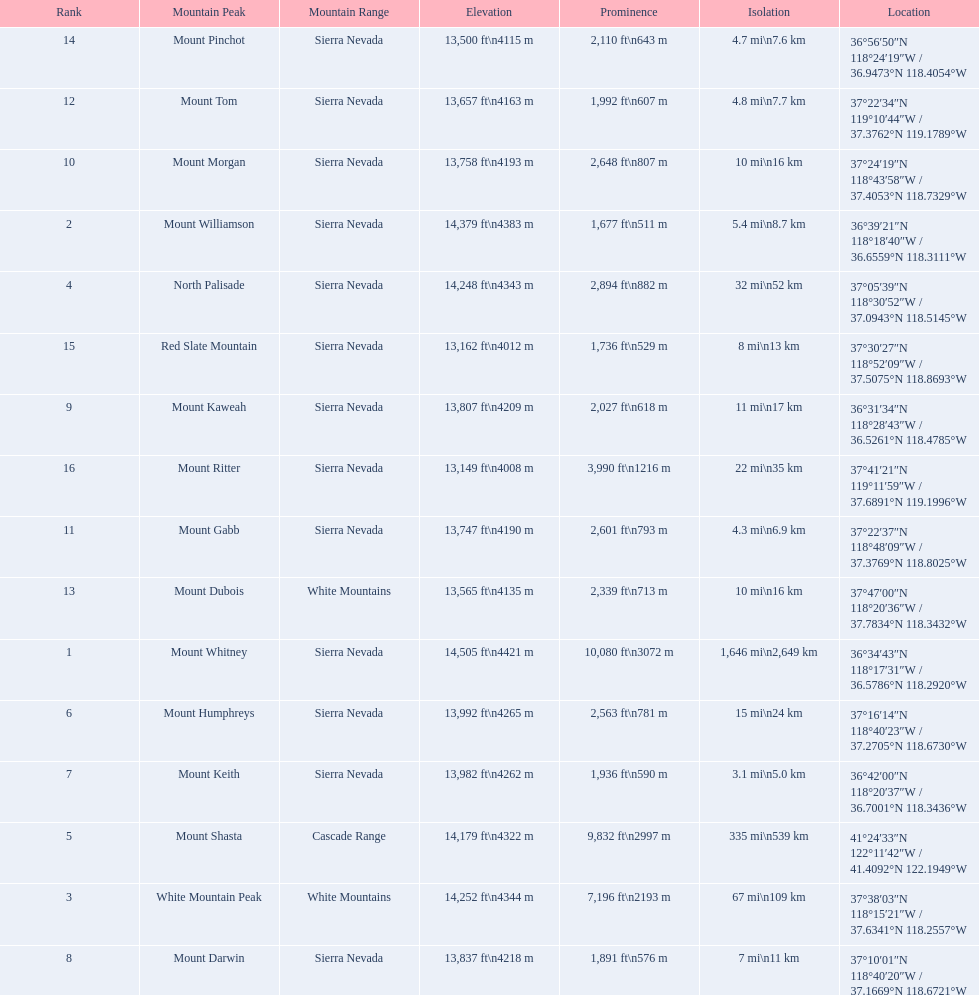What mountain peak is listed for the sierra nevada mountain range? Mount Whitney. What mountain peak has an elevation of 14,379ft? Mount Williamson. Which mountain is listed for the cascade range? Mount Shasta. 